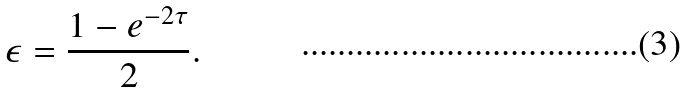<formula> <loc_0><loc_0><loc_500><loc_500>\epsilon = \frac { 1 - e ^ { - 2 \tau } } { 2 } .</formula> 